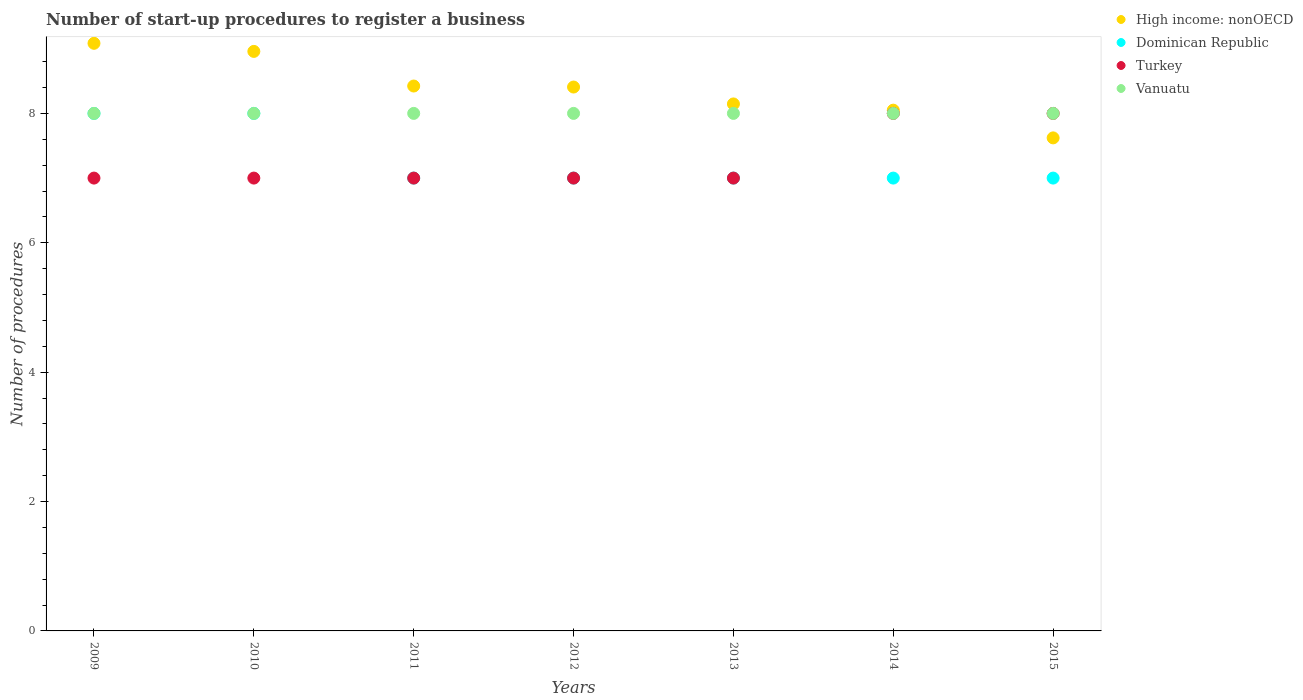Is the number of dotlines equal to the number of legend labels?
Keep it short and to the point. Yes. What is the number of procedures required to register a business in Turkey in 2009?
Offer a terse response. 7. Across all years, what is the maximum number of procedures required to register a business in High income: nonOECD?
Your response must be concise. 9.08. Across all years, what is the minimum number of procedures required to register a business in Turkey?
Offer a terse response. 7. In which year was the number of procedures required to register a business in Vanuatu maximum?
Your answer should be compact. 2009. What is the total number of procedures required to register a business in High income: nonOECD in the graph?
Give a very brief answer. 58.69. What is the difference between the number of procedures required to register a business in Vanuatu in 2011 and that in 2012?
Offer a terse response. 0. What is the difference between the number of procedures required to register a business in Dominican Republic in 2015 and the number of procedures required to register a business in Vanuatu in 2010?
Your answer should be compact. -1. What is the average number of procedures required to register a business in Vanuatu per year?
Your answer should be compact. 8. In the year 2012, what is the difference between the number of procedures required to register a business in Vanuatu and number of procedures required to register a business in Turkey?
Your answer should be very brief. 1. What is the ratio of the number of procedures required to register a business in High income: nonOECD in 2011 to that in 2015?
Your answer should be compact. 1.11. Is the number of procedures required to register a business in Vanuatu in 2013 less than that in 2014?
Provide a short and direct response. No. Is the difference between the number of procedures required to register a business in Vanuatu in 2012 and 2013 greater than the difference between the number of procedures required to register a business in Turkey in 2012 and 2013?
Offer a terse response. No. What is the difference between the highest and the lowest number of procedures required to register a business in Dominican Republic?
Offer a very short reply. 1. In how many years, is the number of procedures required to register a business in Dominican Republic greater than the average number of procedures required to register a business in Dominican Republic taken over all years?
Keep it short and to the point. 2. Does the number of procedures required to register a business in Vanuatu monotonically increase over the years?
Provide a succinct answer. No. Does the graph contain any zero values?
Keep it short and to the point. No. Where does the legend appear in the graph?
Offer a very short reply. Top right. How many legend labels are there?
Keep it short and to the point. 4. How are the legend labels stacked?
Your response must be concise. Vertical. What is the title of the graph?
Make the answer very short. Number of start-up procedures to register a business. What is the label or title of the X-axis?
Give a very brief answer. Years. What is the label or title of the Y-axis?
Your response must be concise. Number of procedures. What is the Number of procedures of High income: nonOECD in 2009?
Your response must be concise. 9.08. What is the Number of procedures in Dominican Republic in 2009?
Your answer should be compact. 8. What is the Number of procedures of Vanuatu in 2009?
Your response must be concise. 8. What is the Number of procedures of High income: nonOECD in 2010?
Offer a terse response. 8.96. What is the Number of procedures of High income: nonOECD in 2011?
Offer a terse response. 8.42. What is the Number of procedures of High income: nonOECD in 2012?
Provide a succinct answer. 8.41. What is the Number of procedures in Turkey in 2012?
Provide a short and direct response. 7. What is the Number of procedures of High income: nonOECD in 2013?
Give a very brief answer. 8.15. What is the Number of procedures of Dominican Republic in 2013?
Make the answer very short. 7. What is the Number of procedures in High income: nonOECD in 2014?
Your answer should be compact. 8.05. What is the Number of procedures of Turkey in 2014?
Your answer should be compact. 8. What is the Number of procedures in High income: nonOECD in 2015?
Your answer should be very brief. 7.62. What is the Number of procedures in Dominican Republic in 2015?
Make the answer very short. 7. Across all years, what is the maximum Number of procedures in High income: nonOECD?
Ensure brevity in your answer.  9.08. Across all years, what is the maximum Number of procedures in Dominican Republic?
Provide a short and direct response. 8. Across all years, what is the minimum Number of procedures of High income: nonOECD?
Offer a terse response. 7.62. Across all years, what is the minimum Number of procedures of Dominican Republic?
Offer a terse response. 7. What is the total Number of procedures in High income: nonOECD in the graph?
Your response must be concise. 58.69. What is the total Number of procedures in Dominican Republic in the graph?
Ensure brevity in your answer.  51. What is the total Number of procedures of Turkey in the graph?
Ensure brevity in your answer.  51. What is the total Number of procedures of Vanuatu in the graph?
Your answer should be very brief. 56. What is the difference between the Number of procedures in High income: nonOECD in 2009 and that in 2010?
Provide a succinct answer. 0.12. What is the difference between the Number of procedures of Dominican Republic in 2009 and that in 2010?
Give a very brief answer. 0. What is the difference between the Number of procedures in Turkey in 2009 and that in 2010?
Your response must be concise. 0. What is the difference between the Number of procedures in Vanuatu in 2009 and that in 2010?
Keep it short and to the point. 0. What is the difference between the Number of procedures in High income: nonOECD in 2009 and that in 2011?
Provide a short and direct response. 0.66. What is the difference between the Number of procedures in Turkey in 2009 and that in 2011?
Offer a very short reply. 0. What is the difference between the Number of procedures of High income: nonOECD in 2009 and that in 2012?
Your response must be concise. 0.68. What is the difference between the Number of procedures in Dominican Republic in 2009 and that in 2012?
Make the answer very short. 1. What is the difference between the Number of procedures of Turkey in 2009 and that in 2012?
Provide a succinct answer. 0. What is the difference between the Number of procedures of Vanuatu in 2009 and that in 2012?
Ensure brevity in your answer.  0. What is the difference between the Number of procedures of High income: nonOECD in 2009 and that in 2013?
Make the answer very short. 0.94. What is the difference between the Number of procedures of Turkey in 2009 and that in 2013?
Ensure brevity in your answer.  0. What is the difference between the Number of procedures of Vanuatu in 2009 and that in 2013?
Keep it short and to the point. 0. What is the difference between the Number of procedures in High income: nonOECD in 2009 and that in 2014?
Provide a succinct answer. 1.03. What is the difference between the Number of procedures in Turkey in 2009 and that in 2014?
Ensure brevity in your answer.  -1. What is the difference between the Number of procedures in Vanuatu in 2009 and that in 2014?
Keep it short and to the point. 0. What is the difference between the Number of procedures of High income: nonOECD in 2009 and that in 2015?
Offer a terse response. 1.46. What is the difference between the Number of procedures in Dominican Republic in 2009 and that in 2015?
Offer a terse response. 1. What is the difference between the Number of procedures in Vanuatu in 2009 and that in 2015?
Give a very brief answer. 0. What is the difference between the Number of procedures of High income: nonOECD in 2010 and that in 2011?
Your response must be concise. 0.54. What is the difference between the Number of procedures in Dominican Republic in 2010 and that in 2011?
Your answer should be compact. 1. What is the difference between the Number of procedures in Turkey in 2010 and that in 2011?
Give a very brief answer. 0. What is the difference between the Number of procedures in Vanuatu in 2010 and that in 2011?
Your answer should be very brief. 0. What is the difference between the Number of procedures in High income: nonOECD in 2010 and that in 2012?
Your answer should be compact. 0.55. What is the difference between the Number of procedures of Dominican Republic in 2010 and that in 2012?
Your response must be concise. 1. What is the difference between the Number of procedures in Vanuatu in 2010 and that in 2012?
Keep it short and to the point. 0. What is the difference between the Number of procedures of High income: nonOECD in 2010 and that in 2013?
Provide a short and direct response. 0.81. What is the difference between the Number of procedures of Dominican Republic in 2010 and that in 2013?
Provide a succinct answer. 1. What is the difference between the Number of procedures of High income: nonOECD in 2010 and that in 2014?
Your answer should be compact. 0.91. What is the difference between the Number of procedures in Dominican Republic in 2010 and that in 2014?
Your answer should be very brief. 1. What is the difference between the Number of procedures of Turkey in 2010 and that in 2014?
Give a very brief answer. -1. What is the difference between the Number of procedures of Vanuatu in 2010 and that in 2014?
Provide a short and direct response. 0. What is the difference between the Number of procedures of High income: nonOECD in 2010 and that in 2015?
Give a very brief answer. 1.34. What is the difference between the Number of procedures of Turkey in 2010 and that in 2015?
Your answer should be compact. -1. What is the difference between the Number of procedures of Vanuatu in 2010 and that in 2015?
Your response must be concise. 0. What is the difference between the Number of procedures of High income: nonOECD in 2011 and that in 2012?
Keep it short and to the point. 0.02. What is the difference between the Number of procedures of Vanuatu in 2011 and that in 2012?
Provide a short and direct response. 0. What is the difference between the Number of procedures in High income: nonOECD in 2011 and that in 2013?
Make the answer very short. 0.28. What is the difference between the Number of procedures in Dominican Republic in 2011 and that in 2013?
Your answer should be very brief. 0. What is the difference between the Number of procedures in High income: nonOECD in 2011 and that in 2014?
Give a very brief answer. 0.37. What is the difference between the Number of procedures of Dominican Republic in 2011 and that in 2014?
Offer a very short reply. 0. What is the difference between the Number of procedures in Turkey in 2011 and that in 2014?
Ensure brevity in your answer.  -1. What is the difference between the Number of procedures of Vanuatu in 2011 and that in 2014?
Make the answer very short. 0. What is the difference between the Number of procedures in High income: nonOECD in 2011 and that in 2015?
Keep it short and to the point. 0.8. What is the difference between the Number of procedures of Dominican Republic in 2011 and that in 2015?
Make the answer very short. 0. What is the difference between the Number of procedures of High income: nonOECD in 2012 and that in 2013?
Provide a short and direct response. 0.26. What is the difference between the Number of procedures in Dominican Republic in 2012 and that in 2013?
Provide a succinct answer. 0. What is the difference between the Number of procedures in Turkey in 2012 and that in 2013?
Your response must be concise. 0. What is the difference between the Number of procedures in High income: nonOECD in 2012 and that in 2014?
Offer a very short reply. 0.36. What is the difference between the Number of procedures of Vanuatu in 2012 and that in 2014?
Provide a succinct answer. 0. What is the difference between the Number of procedures in High income: nonOECD in 2012 and that in 2015?
Keep it short and to the point. 0.79. What is the difference between the Number of procedures of Dominican Republic in 2012 and that in 2015?
Keep it short and to the point. 0. What is the difference between the Number of procedures of High income: nonOECD in 2013 and that in 2014?
Provide a short and direct response. 0.1. What is the difference between the Number of procedures of Dominican Republic in 2013 and that in 2014?
Keep it short and to the point. 0. What is the difference between the Number of procedures of Vanuatu in 2013 and that in 2014?
Provide a short and direct response. 0. What is the difference between the Number of procedures in High income: nonOECD in 2013 and that in 2015?
Provide a succinct answer. 0.53. What is the difference between the Number of procedures in Turkey in 2013 and that in 2015?
Provide a succinct answer. -1. What is the difference between the Number of procedures in Vanuatu in 2013 and that in 2015?
Ensure brevity in your answer.  0. What is the difference between the Number of procedures in High income: nonOECD in 2014 and that in 2015?
Your answer should be compact. 0.43. What is the difference between the Number of procedures in Dominican Republic in 2014 and that in 2015?
Keep it short and to the point. 0. What is the difference between the Number of procedures of Vanuatu in 2014 and that in 2015?
Ensure brevity in your answer.  0. What is the difference between the Number of procedures in High income: nonOECD in 2009 and the Number of procedures in Turkey in 2010?
Provide a short and direct response. 2.08. What is the difference between the Number of procedures in High income: nonOECD in 2009 and the Number of procedures in Vanuatu in 2010?
Offer a terse response. 1.08. What is the difference between the Number of procedures of Dominican Republic in 2009 and the Number of procedures of Vanuatu in 2010?
Your response must be concise. 0. What is the difference between the Number of procedures of Turkey in 2009 and the Number of procedures of Vanuatu in 2010?
Offer a very short reply. -1. What is the difference between the Number of procedures of High income: nonOECD in 2009 and the Number of procedures of Dominican Republic in 2011?
Your answer should be compact. 2.08. What is the difference between the Number of procedures of High income: nonOECD in 2009 and the Number of procedures of Turkey in 2011?
Keep it short and to the point. 2.08. What is the difference between the Number of procedures in Dominican Republic in 2009 and the Number of procedures in Vanuatu in 2011?
Your answer should be compact. 0. What is the difference between the Number of procedures of Turkey in 2009 and the Number of procedures of Vanuatu in 2011?
Make the answer very short. -1. What is the difference between the Number of procedures in High income: nonOECD in 2009 and the Number of procedures in Dominican Republic in 2012?
Your answer should be very brief. 2.08. What is the difference between the Number of procedures of High income: nonOECD in 2009 and the Number of procedures of Turkey in 2012?
Provide a short and direct response. 2.08. What is the difference between the Number of procedures of Dominican Republic in 2009 and the Number of procedures of Turkey in 2012?
Provide a succinct answer. 1. What is the difference between the Number of procedures in High income: nonOECD in 2009 and the Number of procedures in Dominican Republic in 2013?
Ensure brevity in your answer.  2.08. What is the difference between the Number of procedures in High income: nonOECD in 2009 and the Number of procedures in Turkey in 2013?
Provide a short and direct response. 2.08. What is the difference between the Number of procedures in Dominican Republic in 2009 and the Number of procedures in Vanuatu in 2013?
Keep it short and to the point. 0. What is the difference between the Number of procedures of Turkey in 2009 and the Number of procedures of Vanuatu in 2013?
Offer a terse response. -1. What is the difference between the Number of procedures of High income: nonOECD in 2009 and the Number of procedures of Dominican Republic in 2014?
Offer a very short reply. 2.08. What is the difference between the Number of procedures in High income: nonOECD in 2009 and the Number of procedures in Turkey in 2014?
Offer a terse response. 1.08. What is the difference between the Number of procedures of Dominican Republic in 2009 and the Number of procedures of Turkey in 2014?
Give a very brief answer. 0. What is the difference between the Number of procedures in High income: nonOECD in 2009 and the Number of procedures in Dominican Republic in 2015?
Your response must be concise. 2.08. What is the difference between the Number of procedures of High income: nonOECD in 2009 and the Number of procedures of Vanuatu in 2015?
Keep it short and to the point. 1.08. What is the difference between the Number of procedures of Dominican Republic in 2009 and the Number of procedures of Turkey in 2015?
Provide a short and direct response. 0. What is the difference between the Number of procedures in Dominican Republic in 2009 and the Number of procedures in Vanuatu in 2015?
Keep it short and to the point. 0. What is the difference between the Number of procedures of High income: nonOECD in 2010 and the Number of procedures of Dominican Republic in 2011?
Give a very brief answer. 1.96. What is the difference between the Number of procedures in High income: nonOECD in 2010 and the Number of procedures in Turkey in 2011?
Provide a succinct answer. 1.96. What is the difference between the Number of procedures of Dominican Republic in 2010 and the Number of procedures of Turkey in 2011?
Offer a very short reply. 1. What is the difference between the Number of procedures of High income: nonOECD in 2010 and the Number of procedures of Dominican Republic in 2012?
Your response must be concise. 1.96. What is the difference between the Number of procedures in High income: nonOECD in 2010 and the Number of procedures in Turkey in 2012?
Provide a short and direct response. 1.96. What is the difference between the Number of procedures of High income: nonOECD in 2010 and the Number of procedures of Dominican Republic in 2013?
Provide a succinct answer. 1.96. What is the difference between the Number of procedures in High income: nonOECD in 2010 and the Number of procedures in Turkey in 2013?
Your answer should be compact. 1.96. What is the difference between the Number of procedures of High income: nonOECD in 2010 and the Number of procedures of Vanuatu in 2013?
Offer a terse response. 0.96. What is the difference between the Number of procedures of Dominican Republic in 2010 and the Number of procedures of Turkey in 2013?
Offer a terse response. 1. What is the difference between the Number of procedures in High income: nonOECD in 2010 and the Number of procedures in Dominican Republic in 2014?
Your answer should be compact. 1.96. What is the difference between the Number of procedures of High income: nonOECD in 2010 and the Number of procedures of Vanuatu in 2014?
Make the answer very short. 0.96. What is the difference between the Number of procedures in Turkey in 2010 and the Number of procedures in Vanuatu in 2014?
Provide a short and direct response. -1. What is the difference between the Number of procedures of High income: nonOECD in 2010 and the Number of procedures of Dominican Republic in 2015?
Ensure brevity in your answer.  1.96. What is the difference between the Number of procedures in High income: nonOECD in 2010 and the Number of procedures in Turkey in 2015?
Your answer should be very brief. 0.96. What is the difference between the Number of procedures of High income: nonOECD in 2010 and the Number of procedures of Vanuatu in 2015?
Provide a succinct answer. 0.96. What is the difference between the Number of procedures of High income: nonOECD in 2011 and the Number of procedures of Dominican Republic in 2012?
Your answer should be very brief. 1.42. What is the difference between the Number of procedures in High income: nonOECD in 2011 and the Number of procedures in Turkey in 2012?
Keep it short and to the point. 1.42. What is the difference between the Number of procedures of High income: nonOECD in 2011 and the Number of procedures of Vanuatu in 2012?
Provide a succinct answer. 0.42. What is the difference between the Number of procedures in Dominican Republic in 2011 and the Number of procedures in Vanuatu in 2012?
Keep it short and to the point. -1. What is the difference between the Number of procedures in Turkey in 2011 and the Number of procedures in Vanuatu in 2012?
Offer a terse response. -1. What is the difference between the Number of procedures in High income: nonOECD in 2011 and the Number of procedures in Dominican Republic in 2013?
Make the answer very short. 1.42. What is the difference between the Number of procedures in High income: nonOECD in 2011 and the Number of procedures in Turkey in 2013?
Offer a terse response. 1.42. What is the difference between the Number of procedures in High income: nonOECD in 2011 and the Number of procedures in Vanuatu in 2013?
Provide a short and direct response. 0.42. What is the difference between the Number of procedures in Dominican Republic in 2011 and the Number of procedures in Turkey in 2013?
Offer a very short reply. 0. What is the difference between the Number of procedures of Dominican Republic in 2011 and the Number of procedures of Vanuatu in 2013?
Offer a very short reply. -1. What is the difference between the Number of procedures in High income: nonOECD in 2011 and the Number of procedures in Dominican Republic in 2014?
Offer a terse response. 1.42. What is the difference between the Number of procedures of High income: nonOECD in 2011 and the Number of procedures of Turkey in 2014?
Provide a short and direct response. 0.42. What is the difference between the Number of procedures in High income: nonOECD in 2011 and the Number of procedures in Vanuatu in 2014?
Offer a terse response. 0.42. What is the difference between the Number of procedures of Dominican Republic in 2011 and the Number of procedures of Turkey in 2014?
Provide a short and direct response. -1. What is the difference between the Number of procedures in Dominican Republic in 2011 and the Number of procedures in Vanuatu in 2014?
Provide a short and direct response. -1. What is the difference between the Number of procedures of High income: nonOECD in 2011 and the Number of procedures of Dominican Republic in 2015?
Your answer should be very brief. 1.42. What is the difference between the Number of procedures in High income: nonOECD in 2011 and the Number of procedures in Turkey in 2015?
Provide a short and direct response. 0.42. What is the difference between the Number of procedures of High income: nonOECD in 2011 and the Number of procedures of Vanuatu in 2015?
Your response must be concise. 0.42. What is the difference between the Number of procedures of Turkey in 2011 and the Number of procedures of Vanuatu in 2015?
Give a very brief answer. -1. What is the difference between the Number of procedures in High income: nonOECD in 2012 and the Number of procedures in Dominican Republic in 2013?
Provide a succinct answer. 1.41. What is the difference between the Number of procedures in High income: nonOECD in 2012 and the Number of procedures in Turkey in 2013?
Your answer should be compact. 1.41. What is the difference between the Number of procedures of High income: nonOECD in 2012 and the Number of procedures of Vanuatu in 2013?
Your response must be concise. 0.41. What is the difference between the Number of procedures in Turkey in 2012 and the Number of procedures in Vanuatu in 2013?
Provide a short and direct response. -1. What is the difference between the Number of procedures in High income: nonOECD in 2012 and the Number of procedures in Dominican Republic in 2014?
Ensure brevity in your answer.  1.41. What is the difference between the Number of procedures in High income: nonOECD in 2012 and the Number of procedures in Turkey in 2014?
Make the answer very short. 0.41. What is the difference between the Number of procedures of High income: nonOECD in 2012 and the Number of procedures of Vanuatu in 2014?
Make the answer very short. 0.41. What is the difference between the Number of procedures in Dominican Republic in 2012 and the Number of procedures in Turkey in 2014?
Your answer should be very brief. -1. What is the difference between the Number of procedures of Turkey in 2012 and the Number of procedures of Vanuatu in 2014?
Your response must be concise. -1. What is the difference between the Number of procedures in High income: nonOECD in 2012 and the Number of procedures in Dominican Republic in 2015?
Ensure brevity in your answer.  1.41. What is the difference between the Number of procedures in High income: nonOECD in 2012 and the Number of procedures in Turkey in 2015?
Your answer should be compact. 0.41. What is the difference between the Number of procedures of High income: nonOECD in 2012 and the Number of procedures of Vanuatu in 2015?
Your answer should be compact. 0.41. What is the difference between the Number of procedures in Dominican Republic in 2012 and the Number of procedures in Turkey in 2015?
Your answer should be compact. -1. What is the difference between the Number of procedures of Dominican Republic in 2012 and the Number of procedures of Vanuatu in 2015?
Provide a succinct answer. -1. What is the difference between the Number of procedures in High income: nonOECD in 2013 and the Number of procedures in Dominican Republic in 2014?
Keep it short and to the point. 1.15. What is the difference between the Number of procedures of High income: nonOECD in 2013 and the Number of procedures of Turkey in 2014?
Offer a very short reply. 0.15. What is the difference between the Number of procedures of High income: nonOECD in 2013 and the Number of procedures of Vanuatu in 2014?
Offer a terse response. 0.15. What is the difference between the Number of procedures of Dominican Republic in 2013 and the Number of procedures of Turkey in 2014?
Offer a very short reply. -1. What is the difference between the Number of procedures of Dominican Republic in 2013 and the Number of procedures of Vanuatu in 2014?
Offer a terse response. -1. What is the difference between the Number of procedures of Turkey in 2013 and the Number of procedures of Vanuatu in 2014?
Keep it short and to the point. -1. What is the difference between the Number of procedures of High income: nonOECD in 2013 and the Number of procedures of Dominican Republic in 2015?
Give a very brief answer. 1.15. What is the difference between the Number of procedures of High income: nonOECD in 2013 and the Number of procedures of Turkey in 2015?
Ensure brevity in your answer.  0.15. What is the difference between the Number of procedures of High income: nonOECD in 2013 and the Number of procedures of Vanuatu in 2015?
Keep it short and to the point. 0.15. What is the difference between the Number of procedures in Dominican Republic in 2013 and the Number of procedures in Vanuatu in 2015?
Keep it short and to the point. -1. What is the difference between the Number of procedures in High income: nonOECD in 2014 and the Number of procedures in Turkey in 2015?
Provide a succinct answer. 0.05. What is the difference between the Number of procedures of High income: nonOECD in 2014 and the Number of procedures of Vanuatu in 2015?
Give a very brief answer. 0.05. What is the difference between the Number of procedures of Dominican Republic in 2014 and the Number of procedures of Turkey in 2015?
Keep it short and to the point. -1. What is the difference between the Number of procedures in Dominican Republic in 2014 and the Number of procedures in Vanuatu in 2015?
Your response must be concise. -1. What is the difference between the Number of procedures of Turkey in 2014 and the Number of procedures of Vanuatu in 2015?
Make the answer very short. 0. What is the average Number of procedures in High income: nonOECD per year?
Ensure brevity in your answer.  8.38. What is the average Number of procedures of Dominican Republic per year?
Make the answer very short. 7.29. What is the average Number of procedures of Turkey per year?
Give a very brief answer. 7.29. In the year 2009, what is the difference between the Number of procedures of High income: nonOECD and Number of procedures of Dominican Republic?
Your answer should be compact. 1.08. In the year 2009, what is the difference between the Number of procedures of High income: nonOECD and Number of procedures of Turkey?
Ensure brevity in your answer.  2.08. In the year 2009, what is the difference between the Number of procedures of Dominican Republic and Number of procedures of Turkey?
Keep it short and to the point. 1. In the year 2009, what is the difference between the Number of procedures in Turkey and Number of procedures in Vanuatu?
Offer a very short reply. -1. In the year 2010, what is the difference between the Number of procedures in High income: nonOECD and Number of procedures in Dominican Republic?
Offer a very short reply. 0.96. In the year 2010, what is the difference between the Number of procedures of High income: nonOECD and Number of procedures of Turkey?
Offer a terse response. 1.96. In the year 2010, what is the difference between the Number of procedures of Dominican Republic and Number of procedures of Vanuatu?
Provide a succinct answer. 0. In the year 2011, what is the difference between the Number of procedures in High income: nonOECD and Number of procedures in Dominican Republic?
Keep it short and to the point. 1.42. In the year 2011, what is the difference between the Number of procedures in High income: nonOECD and Number of procedures in Turkey?
Provide a succinct answer. 1.42. In the year 2011, what is the difference between the Number of procedures in High income: nonOECD and Number of procedures in Vanuatu?
Ensure brevity in your answer.  0.42. In the year 2011, what is the difference between the Number of procedures of Dominican Republic and Number of procedures of Vanuatu?
Provide a short and direct response. -1. In the year 2012, what is the difference between the Number of procedures of High income: nonOECD and Number of procedures of Dominican Republic?
Provide a succinct answer. 1.41. In the year 2012, what is the difference between the Number of procedures in High income: nonOECD and Number of procedures in Turkey?
Make the answer very short. 1.41. In the year 2012, what is the difference between the Number of procedures of High income: nonOECD and Number of procedures of Vanuatu?
Keep it short and to the point. 0.41. In the year 2012, what is the difference between the Number of procedures of Dominican Republic and Number of procedures of Turkey?
Provide a succinct answer. 0. In the year 2012, what is the difference between the Number of procedures in Turkey and Number of procedures in Vanuatu?
Offer a terse response. -1. In the year 2013, what is the difference between the Number of procedures in High income: nonOECD and Number of procedures in Dominican Republic?
Your answer should be very brief. 1.15. In the year 2013, what is the difference between the Number of procedures in High income: nonOECD and Number of procedures in Turkey?
Your answer should be compact. 1.15. In the year 2013, what is the difference between the Number of procedures of High income: nonOECD and Number of procedures of Vanuatu?
Your answer should be very brief. 0.15. In the year 2013, what is the difference between the Number of procedures of Dominican Republic and Number of procedures of Turkey?
Offer a terse response. 0. In the year 2013, what is the difference between the Number of procedures in Dominican Republic and Number of procedures in Vanuatu?
Provide a short and direct response. -1. In the year 2014, what is the difference between the Number of procedures of High income: nonOECD and Number of procedures of Turkey?
Provide a short and direct response. 0.05. In the year 2014, what is the difference between the Number of procedures in Dominican Republic and Number of procedures in Turkey?
Your answer should be compact. -1. In the year 2014, what is the difference between the Number of procedures in Dominican Republic and Number of procedures in Vanuatu?
Give a very brief answer. -1. In the year 2014, what is the difference between the Number of procedures of Turkey and Number of procedures of Vanuatu?
Your response must be concise. 0. In the year 2015, what is the difference between the Number of procedures in High income: nonOECD and Number of procedures in Dominican Republic?
Your response must be concise. 0.62. In the year 2015, what is the difference between the Number of procedures in High income: nonOECD and Number of procedures in Turkey?
Offer a very short reply. -0.38. In the year 2015, what is the difference between the Number of procedures of High income: nonOECD and Number of procedures of Vanuatu?
Your response must be concise. -0.38. In the year 2015, what is the difference between the Number of procedures in Dominican Republic and Number of procedures in Turkey?
Offer a very short reply. -1. In the year 2015, what is the difference between the Number of procedures of Turkey and Number of procedures of Vanuatu?
Ensure brevity in your answer.  0. What is the ratio of the Number of procedures of High income: nonOECD in 2009 to that in 2010?
Give a very brief answer. 1.01. What is the ratio of the Number of procedures of High income: nonOECD in 2009 to that in 2011?
Make the answer very short. 1.08. What is the ratio of the Number of procedures of Dominican Republic in 2009 to that in 2011?
Your answer should be very brief. 1.14. What is the ratio of the Number of procedures of Turkey in 2009 to that in 2011?
Provide a succinct answer. 1. What is the ratio of the Number of procedures of High income: nonOECD in 2009 to that in 2012?
Make the answer very short. 1.08. What is the ratio of the Number of procedures of Turkey in 2009 to that in 2012?
Your answer should be very brief. 1. What is the ratio of the Number of procedures in High income: nonOECD in 2009 to that in 2013?
Give a very brief answer. 1.11. What is the ratio of the Number of procedures of Vanuatu in 2009 to that in 2013?
Your answer should be very brief. 1. What is the ratio of the Number of procedures of High income: nonOECD in 2009 to that in 2014?
Provide a short and direct response. 1.13. What is the ratio of the Number of procedures of Vanuatu in 2009 to that in 2014?
Your answer should be compact. 1. What is the ratio of the Number of procedures of High income: nonOECD in 2009 to that in 2015?
Offer a very short reply. 1.19. What is the ratio of the Number of procedures in Dominican Republic in 2009 to that in 2015?
Offer a very short reply. 1.14. What is the ratio of the Number of procedures in High income: nonOECD in 2010 to that in 2011?
Give a very brief answer. 1.06. What is the ratio of the Number of procedures of Dominican Republic in 2010 to that in 2011?
Provide a succinct answer. 1.14. What is the ratio of the Number of procedures of Turkey in 2010 to that in 2011?
Ensure brevity in your answer.  1. What is the ratio of the Number of procedures in High income: nonOECD in 2010 to that in 2012?
Give a very brief answer. 1.07. What is the ratio of the Number of procedures of Dominican Republic in 2010 to that in 2012?
Keep it short and to the point. 1.14. What is the ratio of the Number of procedures in Vanuatu in 2010 to that in 2012?
Provide a short and direct response. 1. What is the ratio of the Number of procedures of High income: nonOECD in 2010 to that in 2013?
Your answer should be very brief. 1.1. What is the ratio of the Number of procedures in Turkey in 2010 to that in 2013?
Your answer should be very brief. 1. What is the ratio of the Number of procedures in High income: nonOECD in 2010 to that in 2014?
Provide a short and direct response. 1.11. What is the ratio of the Number of procedures of Vanuatu in 2010 to that in 2014?
Ensure brevity in your answer.  1. What is the ratio of the Number of procedures of High income: nonOECD in 2010 to that in 2015?
Offer a very short reply. 1.18. What is the ratio of the Number of procedures of Dominican Republic in 2010 to that in 2015?
Ensure brevity in your answer.  1.14. What is the ratio of the Number of procedures of High income: nonOECD in 2011 to that in 2012?
Offer a terse response. 1. What is the ratio of the Number of procedures of Turkey in 2011 to that in 2012?
Your answer should be compact. 1. What is the ratio of the Number of procedures of High income: nonOECD in 2011 to that in 2013?
Offer a very short reply. 1.03. What is the ratio of the Number of procedures of High income: nonOECD in 2011 to that in 2014?
Give a very brief answer. 1.05. What is the ratio of the Number of procedures in Turkey in 2011 to that in 2014?
Give a very brief answer. 0.88. What is the ratio of the Number of procedures in High income: nonOECD in 2011 to that in 2015?
Give a very brief answer. 1.11. What is the ratio of the Number of procedures of Vanuatu in 2011 to that in 2015?
Give a very brief answer. 1. What is the ratio of the Number of procedures of High income: nonOECD in 2012 to that in 2013?
Offer a very short reply. 1.03. What is the ratio of the Number of procedures in Dominican Republic in 2012 to that in 2013?
Your answer should be very brief. 1. What is the ratio of the Number of procedures in Turkey in 2012 to that in 2013?
Ensure brevity in your answer.  1. What is the ratio of the Number of procedures in High income: nonOECD in 2012 to that in 2014?
Your answer should be very brief. 1.04. What is the ratio of the Number of procedures of Dominican Republic in 2012 to that in 2014?
Offer a very short reply. 1. What is the ratio of the Number of procedures of Turkey in 2012 to that in 2014?
Offer a terse response. 0.88. What is the ratio of the Number of procedures of Vanuatu in 2012 to that in 2014?
Your response must be concise. 1. What is the ratio of the Number of procedures of High income: nonOECD in 2012 to that in 2015?
Make the answer very short. 1.1. What is the ratio of the Number of procedures of Turkey in 2013 to that in 2014?
Your answer should be very brief. 0.88. What is the ratio of the Number of procedures of High income: nonOECD in 2013 to that in 2015?
Offer a very short reply. 1.07. What is the ratio of the Number of procedures in Turkey in 2013 to that in 2015?
Offer a very short reply. 0.88. What is the ratio of the Number of procedures in Vanuatu in 2013 to that in 2015?
Your response must be concise. 1. What is the ratio of the Number of procedures in High income: nonOECD in 2014 to that in 2015?
Offer a very short reply. 1.06. What is the ratio of the Number of procedures in Turkey in 2014 to that in 2015?
Provide a succinct answer. 1. What is the difference between the highest and the second highest Number of procedures in Turkey?
Your response must be concise. 0. What is the difference between the highest and the lowest Number of procedures in High income: nonOECD?
Offer a very short reply. 1.46. What is the difference between the highest and the lowest Number of procedures in Dominican Republic?
Give a very brief answer. 1. What is the difference between the highest and the lowest Number of procedures of Turkey?
Your response must be concise. 1. 